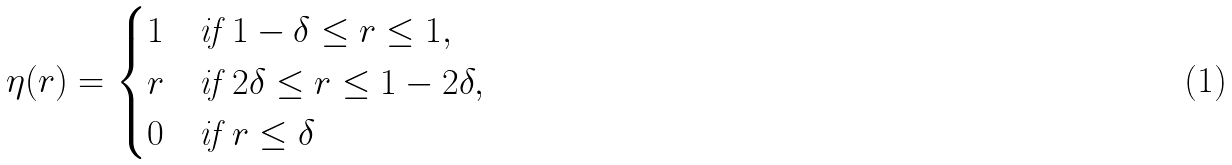<formula> <loc_0><loc_0><loc_500><loc_500>\eta ( r ) = \begin{cases} 1 & \text {if  } 1 - \delta \leq r \leq 1 , \\ r & \text {if } 2 \delta \leq r \leq 1 - 2 \delta , \\ 0 & \text {if } r \leq \delta \end{cases}</formula> 